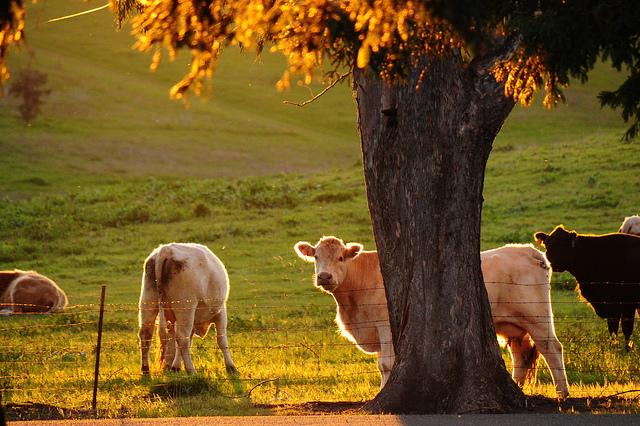What is one of the cows hiding behind?

Choices:
A) airplane
B) truck
C) tree
D) elephant tree 